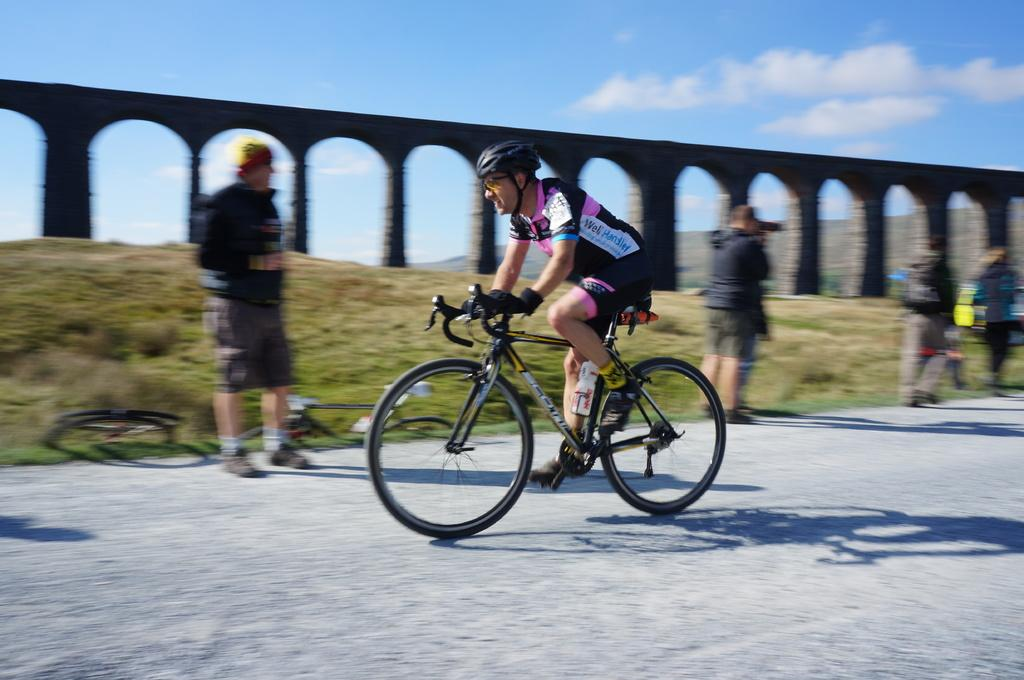What is the main subject of the image? The main subject of the image is a person riding a bicycle. Are there any other people in the image? Yes, there are many people standing at the back of the person riding the bicycle. What can be seen in the background of the image? The sky is visible in the image. What is the condition of the sky in the image? Clouds are present in the sky. What is the size of the boy in the image? There is no boy present in the image; it features a person riding a bicycle with other people standing at the back. Who is the owner of the bicycle in the image? The image does not provide information about the ownership of the bicycle. 